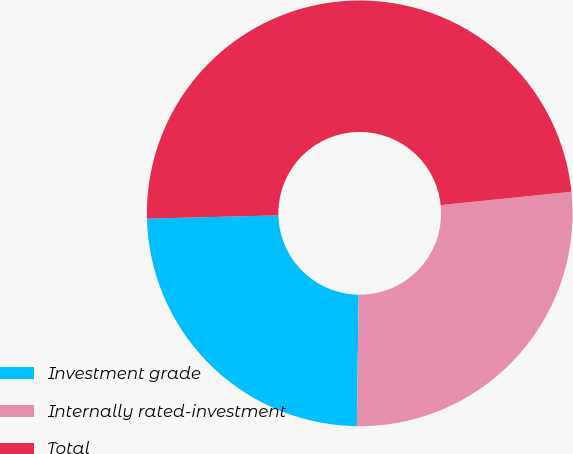Convert chart. <chart><loc_0><loc_0><loc_500><loc_500><pie_chart><fcel>Investment grade<fcel>Internally rated-investment<fcel>Total<nl><fcel>24.39%<fcel>26.83%<fcel>48.78%<nl></chart> 